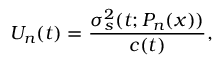<formula> <loc_0><loc_0><loc_500><loc_500>U _ { n } ( t ) = \frac { \sigma _ { s } ^ { 2 } ( t ; P _ { n } ( x ) ) } { c ( t ) } ,</formula> 